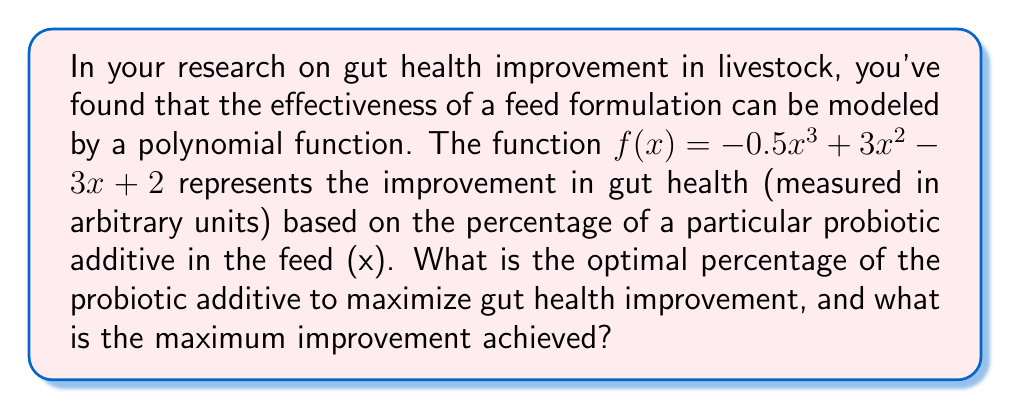Help me with this question. To find the optimal percentage of the probiotic additive and the maximum gut health improvement, we need to find the maximum point of the given function. This can be done by following these steps:

1. Find the derivative of the function:
   $$f'(x) = -1.5x^2 + 6x - 3$$

2. Set the derivative equal to zero and solve for x:
   $$-1.5x^2 + 6x - 3 = 0$$
   
   This is a quadratic equation. We can solve it using the quadratic formula:
   $$x = \frac{-b \pm \sqrt{b^2 - 4ac}}{2a}$$
   
   Where $a = -1.5$, $b = 6$, and $c = -3$

   $$x = \frac{-6 \pm \sqrt{36 - 4(-1.5)(-3)}}{2(-1.5)}$$
   $$x = \frac{-6 \pm \sqrt{36 - 18}}{-3}$$
   $$x = \frac{-6 \pm \sqrt{18}}{-3}$$
   $$x = \frac{-6 \pm 3\sqrt{2}}{-3}$$

   This gives us two solutions:
   $$x_1 = \frac{-6 + 3\sqrt{2}}{-3} = 2 - \sqrt{2}$$
   $$x_2 = \frac{-6 - 3\sqrt{2}}{-3} = 2 + \sqrt{2}$$

3. To determine which solution gives the maximum, we can check the second derivative:
   $$f''(x) = -3x + 6$$
   
   At $x = 2 - \sqrt{2}$:
   $$f''(2 - \sqrt{2}) = -3(2 - \sqrt{2}) + 6 = 3\sqrt{2} > 0$$

   This confirms that $x = 2 - \sqrt{2}$ gives us the maximum point.

4. Calculate the maximum improvement by plugging $x = 2 - \sqrt{2}$ into the original function:
   $$f(2 - \sqrt{2}) = -0.5(2 - \sqrt{2})^3 + 3(2 - \sqrt{2})^2 - 3(2 - \sqrt{2}) + 2$$
   
   This simplifies to:
   $$f(2 - \sqrt{2}) = 2 + \sqrt{2}$$

Therefore, the optimal percentage of the probiotic additive is $(2 - \sqrt{2}) \times 100\% \approx 58.58\%$, and the maximum gut health improvement is $2 + \sqrt{2} \approx 3.41$ units.
Answer: Optimal percentage of probiotic additive: $(2 - \sqrt{2}) \times 100\% \approx 58.58\%$
Maximum gut health improvement: $2 + \sqrt{2} \approx 3.41$ units 